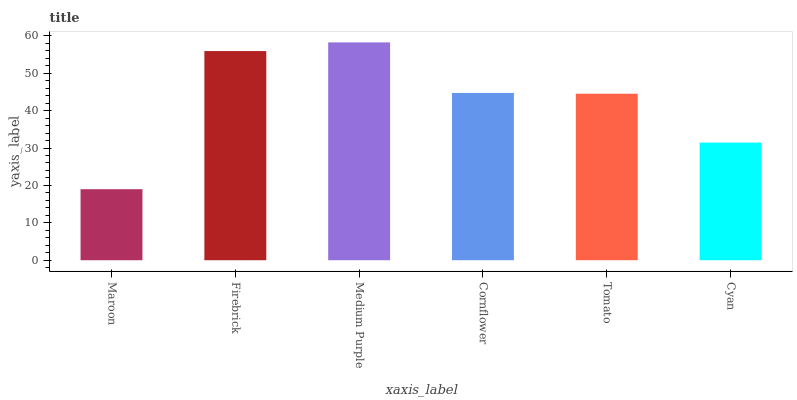Is Firebrick the minimum?
Answer yes or no. No. Is Firebrick the maximum?
Answer yes or no. No. Is Firebrick greater than Maroon?
Answer yes or no. Yes. Is Maroon less than Firebrick?
Answer yes or no. Yes. Is Maroon greater than Firebrick?
Answer yes or no. No. Is Firebrick less than Maroon?
Answer yes or no. No. Is Cornflower the high median?
Answer yes or no. Yes. Is Tomato the low median?
Answer yes or no. Yes. Is Cyan the high median?
Answer yes or no. No. Is Cornflower the low median?
Answer yes or no. No. 